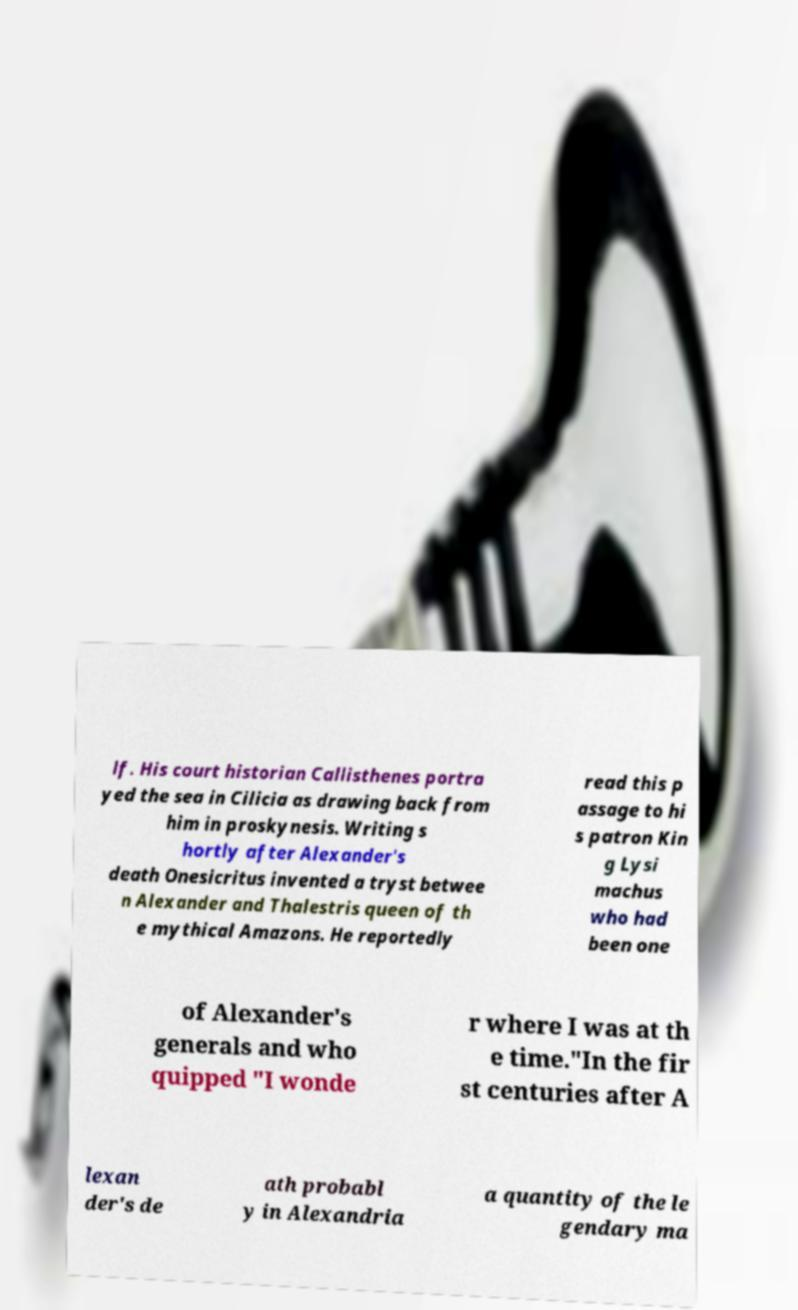Could you assist in decoding the text presented in this image and type it out clearly? lf. His court historian Callisthenes portra yed the sea in Cilicia as drawing back from him in proskynesis. Writing s hortly after Alexander's death Onesicritus invented a tryst betwee n Alexander and Thalestris queen of th e mythical Amazons. He reportedly read this p assage to hi s patron Kin g Lysi machus who had been one of Alexander's generals and who quipped "I wonde r where I was at th e time."In the fir st centuries after A lexan der's de ath probabl y in Alexandria a quantity of the le gendary ma 